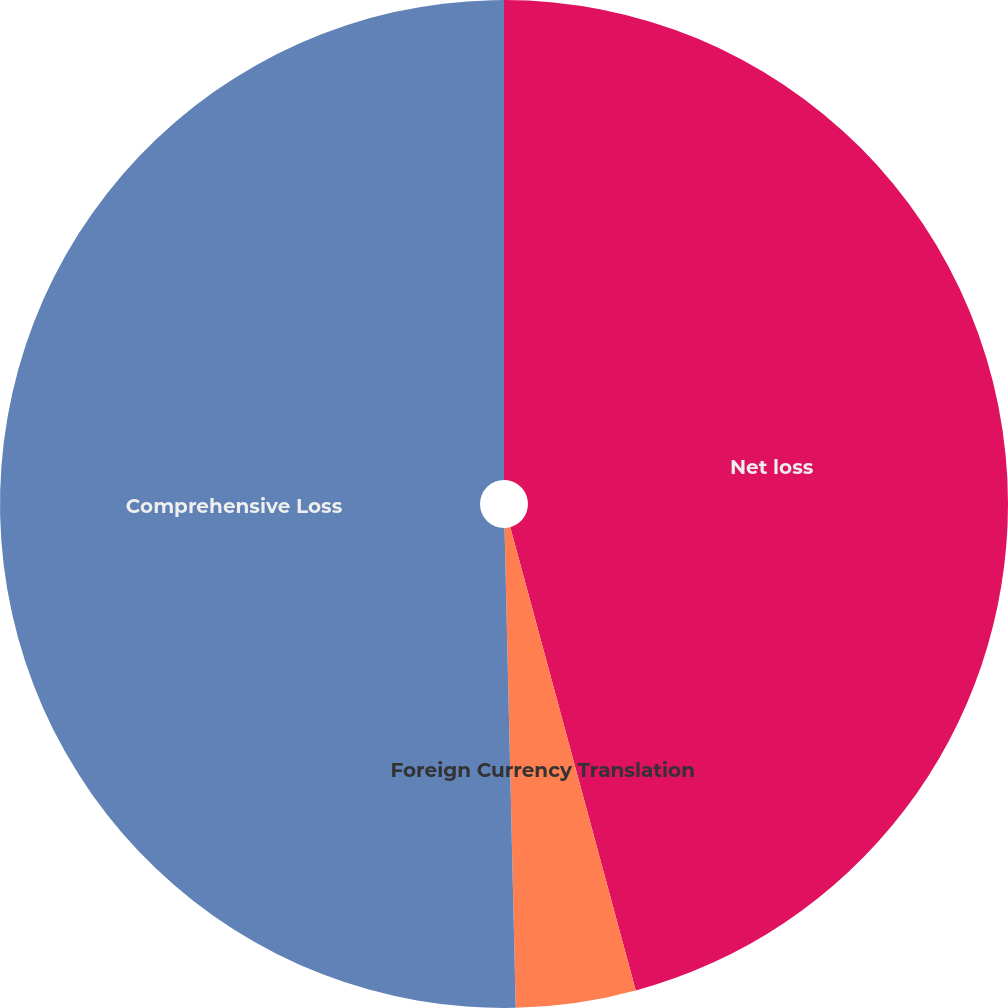<chart> <loc_0><loc_0><loc_500><loc_500><pie_chart><fcel>Net loss<fcel>Foreign Currency Translation<fcel>Comprehensive Loss<nl><fcel>45.79%<fcel>3.84%<fcel>50.37%<nl></chart> 